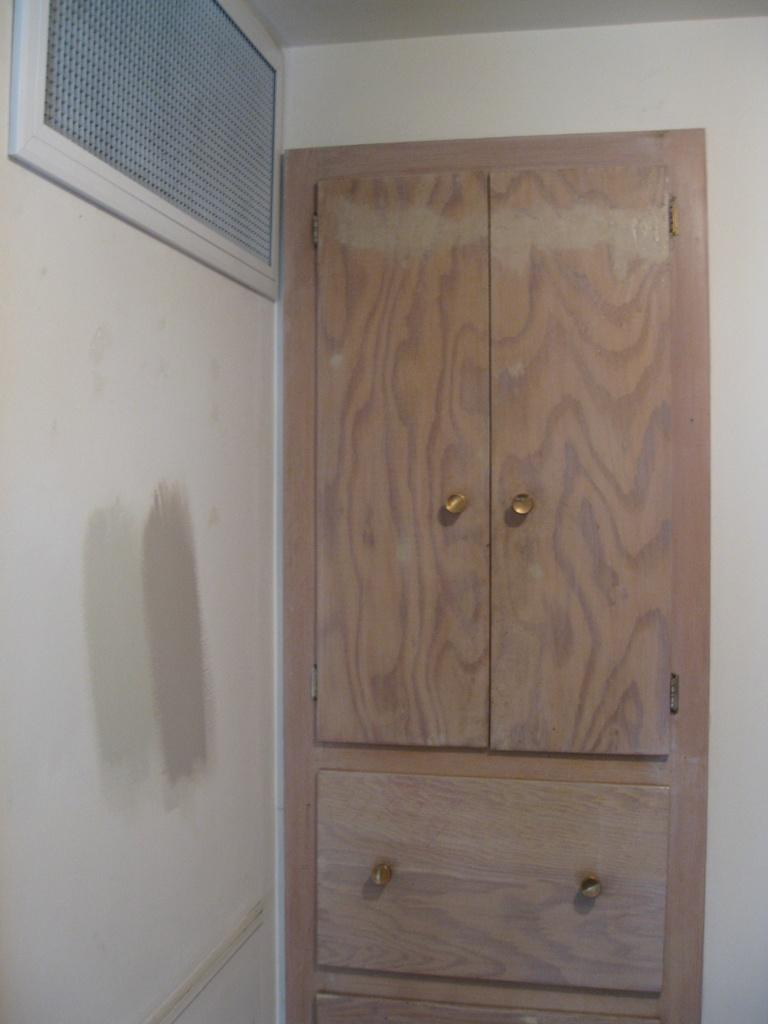What type of furniture is present in the image? There is a cupboard in the image. What can be seen surrounding the cupboard? Walls are visible in the image. What type of art is being performed by the actor in the image? There is no actor or art performance present in the image; it only features a cupboard and walls. 